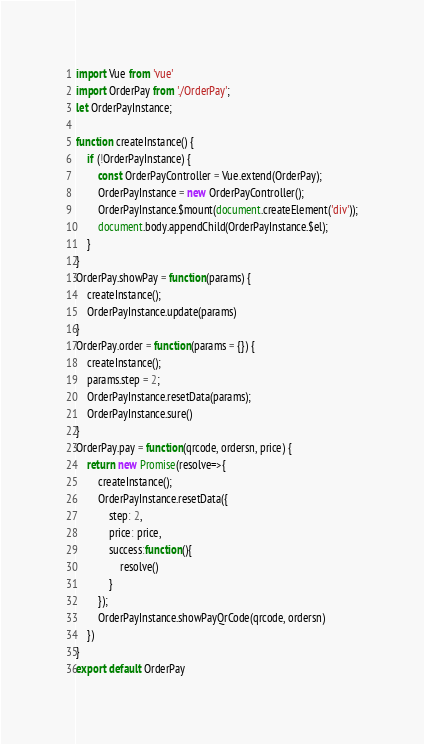Convert code to text. <code><loc_0><loc_0><loc_500><loc_500><_JavaScript_>import Vue from 'vue'
import OrderPay from './OrderPay';
let OrderPayInstance;

function createInstance() {
    if (!OrderPayInstance) {
        const OrderPayController = Vue.extend(OrderPay);
        OrderPayInstance = new OrderPayController();
        OrderPayInstance.$mount(document.createElement('div'));
        document.body.appendChild(OrderPayInstance.$el);
    }
}
OrderPay.showPay = function(params) {
    createInstance();
    OrderPayInstance.update(params)
}
OrderPay.order = function(params = {}) {
    createInstance();
    params.step = 2;
    OrderPayInstance.resetData(params);
    OrderPayInstance.sure()
}
OrderPay.pay = function(qrcode, ordersn, price) {
    return new Promise(resolve=>{
        createInstance();
        OrderPayInstance.resetData({
            step: 2,
            price: price,
            success:function(){
                resolve()
            }
        });
        OrderPayInstance.showPayQrCode(qrcode, ordersn)
    })
}
export default OrderPay</code> 